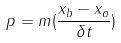<formula> <loc_0><loc_0><loc_500><loc_500>p = m ( \frac { x _ { b } - x _ { a } } { \delta t } )</formula> 